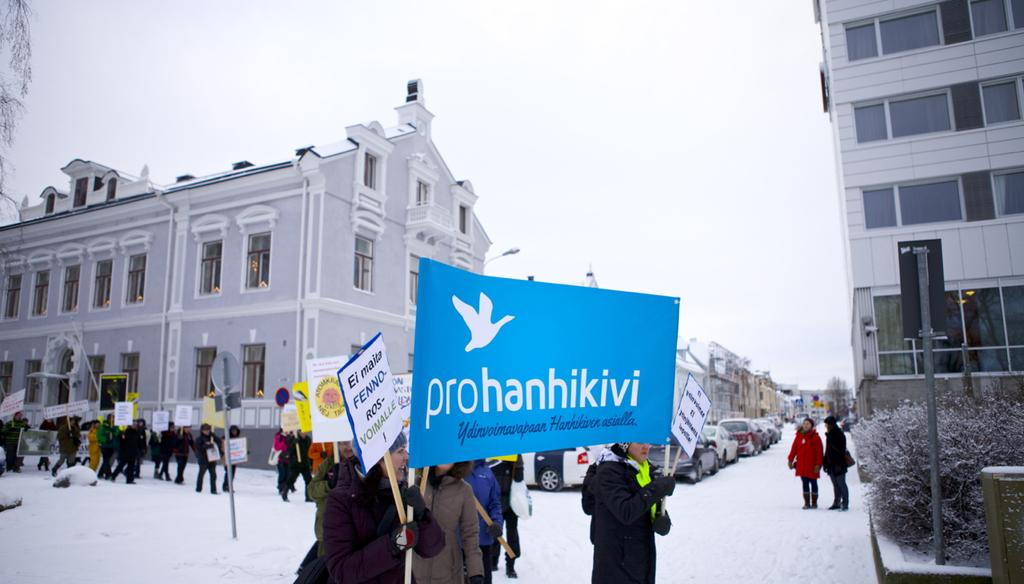Provide a one-sentence caption for the provided image. Protesters supporting Prohanhikivi organization out in the snow. 